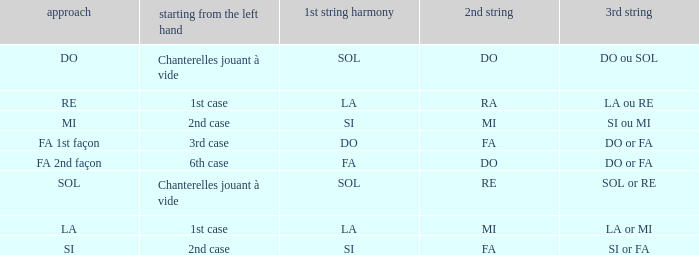For the 2nd string of Ra what is the Depart de la main gauche? 1st case. 